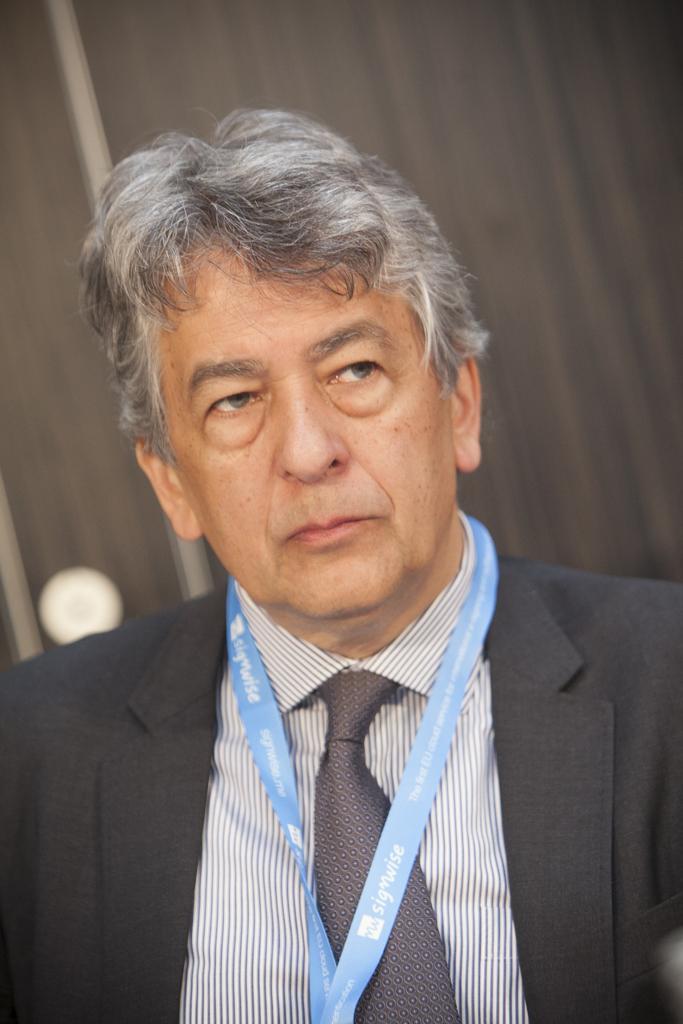Can you describe this image briefly? Here I can see a man wearing a black color suit and looking at the right side. In the background, I can see a curtain and a pole. 